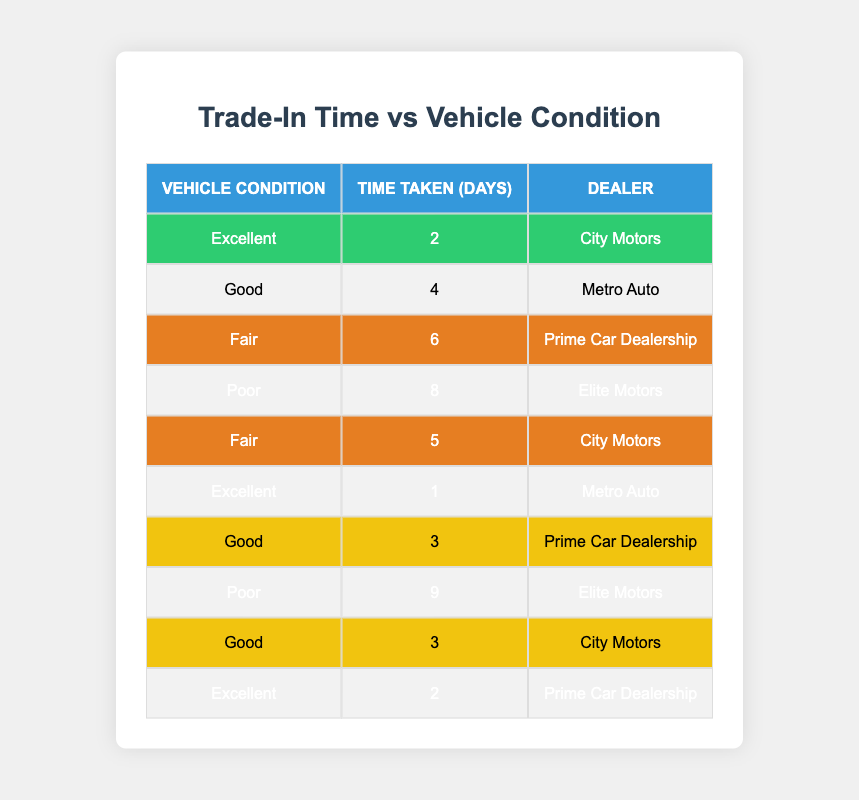What is the longest time taken for a trade-in? The longest time recorded in the table is 9 days, which is associated with a vehicle in poor condition traded in at Elite Motors.
Answer: 9 days What is the average time taken for vehicles in excellent condition? There are three data points for excellent condition: 2 days (City Motors), 1 day (Metro Auto), and 2 days (Prime Car Dealership). The average is calculated as (2 + 1 + 2) / 3 = 5 / 3 = 1.67 days.
Answer: 1.67 days Is it true that vehicles in good condition take less time on average than those in fair condition? For good condition, the times are 4 days (Metro Auto), 3 days (Prime Car Dealership), and 3 days (City Motors), giving an average of (4 + 3 + 3) / 3 = 10 / 3 = 3.33 days. For fair condition, the times are 6 days and 5 days, giving an average of (6 + 5) / 2 = 11 / 2 = 5.5 days. Since 3.33 days is less than 5.5 days, the statement is true.
Answer: Yes What is the total number of days taken for trade-ins across all vehicle conditions? Summing all the times from the table gives: 2 + 4 + 6 + 8 + 5 + 1 + 3 + 9 + 3 + 2 = 43 days in total.
Answer: 43 days What dealer recorded the fastest trade-in for excellent condition vehicles? According to the table, 1 day for excellent condition was recorded by Metro Auto, which is the fastest time among the excellent category.
Answer: Metro Auto What is the median time taken for trade-ins of vehicles in poor condition? The times for poor condition are 8 days and 9 days. Since there are only two values, the median is calculated as (8 + 9) / 2 = 17 / 2 = 8.5 days.
Answer: 8.5 days Which vehicle condition category has the most trade-ins recorded? Counting the entries, excellent has 3, good has 3, fair has 2, and poor has 2. Therefore, excellent and good conditions have the highest number of trade-ins, both at 3.
Answer: Excellent and Good What is the percentage of trade-ins that took more than 5 days? The times greater than 5 days are 6, 8, and 9 days. There are a total of 10 trade-ins, so (3 / 10) * 100 = 30%.
Answer: 30% 